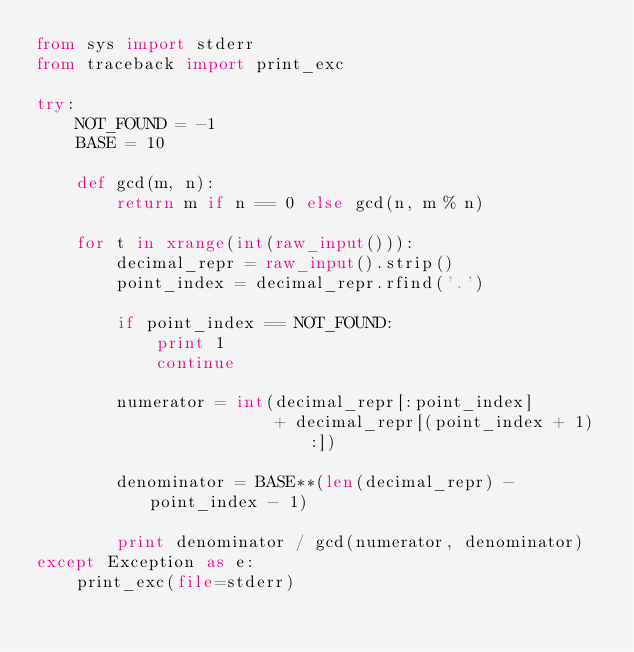<code> <loc_0><loc_0><loc_500><loc_500><_Python_>from sys import stderr
from traceback import print_exc

try:
    NOT_FOUND = -1
    BASE = 10
    
    def gcd(m, n):
        return m if n == 0 else gcd(n, m % n)
        
    for t in xrange(int(raw_input())):
        decimal_repr = raw_input().strip()
        point_index = decimal_repr.rfind('.')
        
        if point_index == NOT_FOUND:
            print 1
            continue
        
        numerator = int(decimal_repr[:point_index]
                        + decimal_repr[(point_index + 1):])
                        
        denominator = BASE**(len(decimal_repr) - point_index - 1)
        
        print denominator / gcd(numerator, denominator)
except Exception as e:
    print_exc(file=stderr)
</code> 